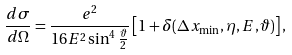<formula> <loc_0><loc_0><loc_500><loc_500>\frac { d \sigma } { d \Omega } = \frac { e ^ { 2 } } { 1 6 E ^ { 2 } \sin ^ { 4 } { \frac { \vartheta } { 2 } } } \left [ 1 + \delta ( \Delta x _ { \min } , \eta , E , \vartheta ) \right ] ,</formula> 